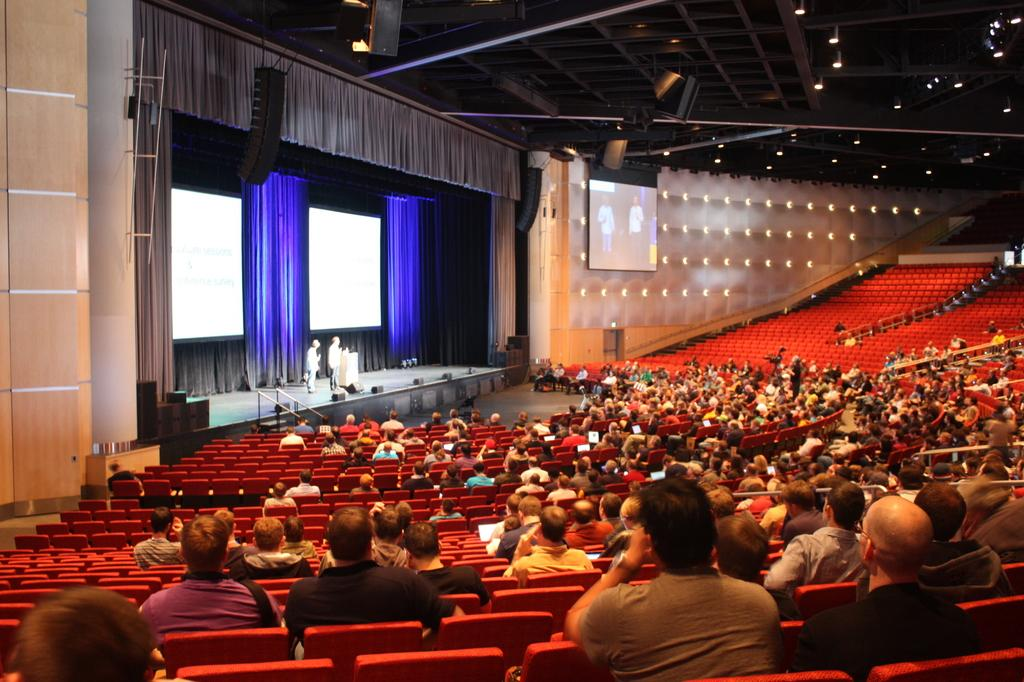What are the people in the image doing? The people in the image are sitting on chairs. What can be seen on the screens in the image? The screens are visible in the image, but their content is not specified. What type of illumination is present in the image? There are lights visible in the image. Can you describe the environment or setting in the image? There are other unspecified objects around the people and screens, but their nature is not detailed. What type of yarn is the dad using to connect the screens in the image? There is no dad or yarn present in the image, and the screens are not being connected. 